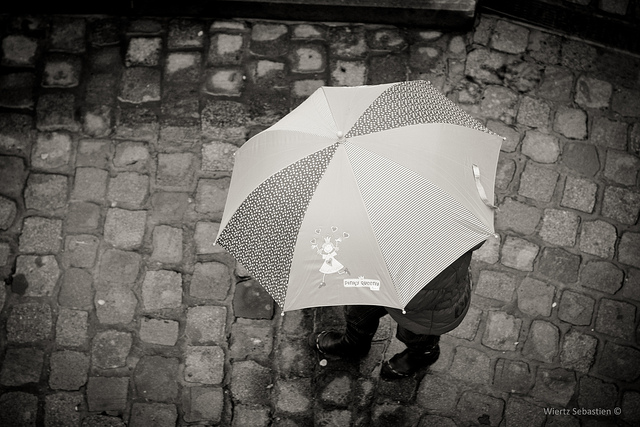Identify the text contained in this image. wiertx Sebastien 